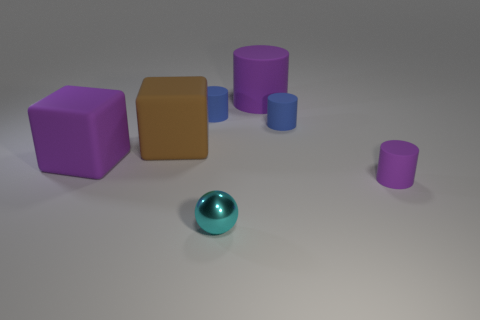Add 2 yellow shiny balls. How many objects exist? 9 Subtract 2 blue cylinders. How many objects are left? 5 Subtract all blocks. How many objects are left? 5 Subtract all green blocks. Subtract all cyan balls. How many blocks are left? 2 Subtract all cyan balls. How many green cubes are left? 0 Subtract all large brown matte cubes. Subtract all big cyan shiny cubes. How many objects are left? 6 Add 5 big purple matte cylinders. How many big purple matte cylinders are left? 6 Add 5 purple rubber things. How many purple rubber things exist? 8 Subtract all brown blocks. How many blocks are left? 1 Subtract all small rubber cylinders. How many cylinders are left? 1 